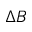Convert formula to latex. <formula><loc_0><loc_0><loc_500><loc_500>\Delta B</formula> 